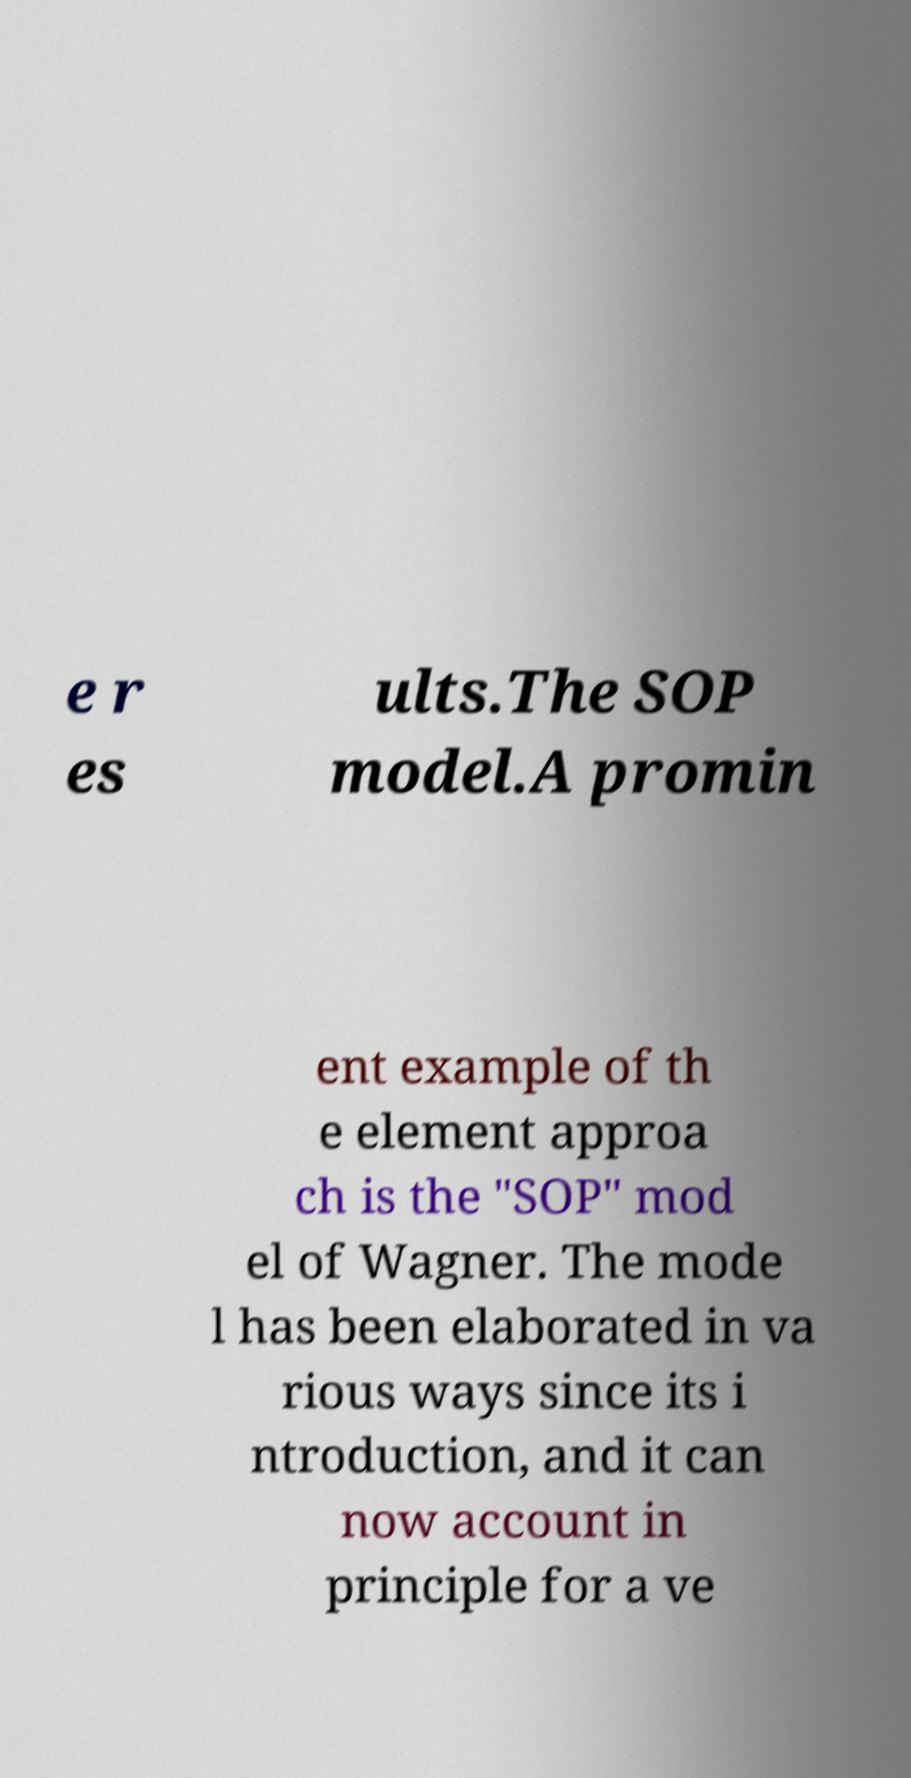I need the written content from this picture converted into text. Can you do that? e r es ults.The SOP model.A promin ent example of th e element approa ch is the "SOP" mod el of Wagner. The mode l has been elaborated in va rious ways since its i ntroduction, and it can now account in principle for a ve 